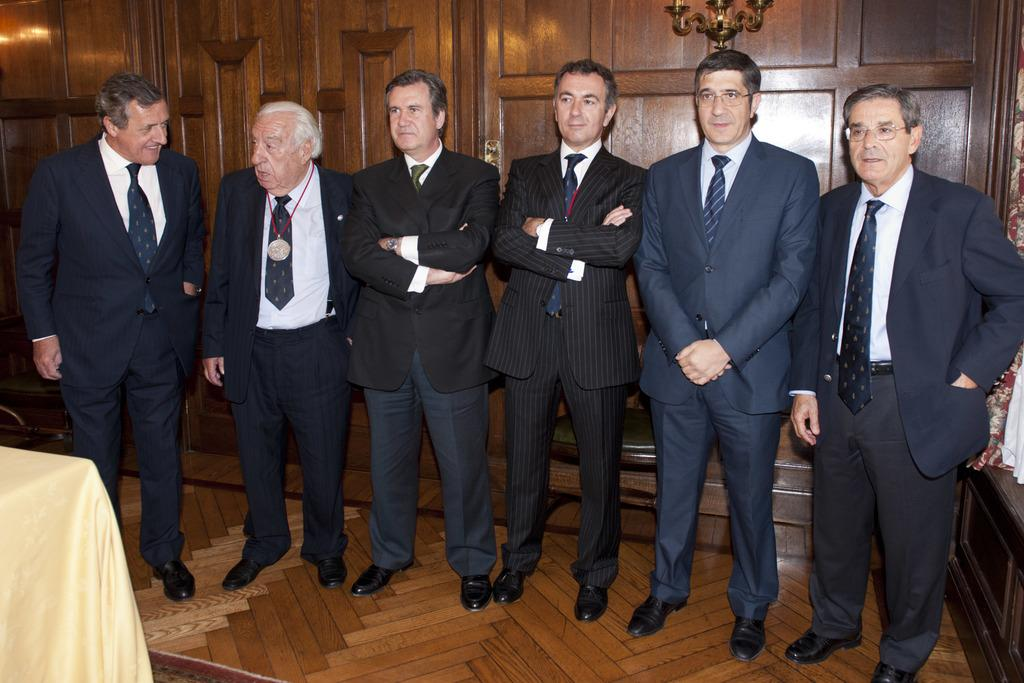How many men are in the image? There are a few men in the image. What are the men wearing? The men are wearing suits. What are the men doing in the image? The men are standing. What is the name of the daughter of the man on the left? There is no mention of a daughter or a man on the left in the image. 